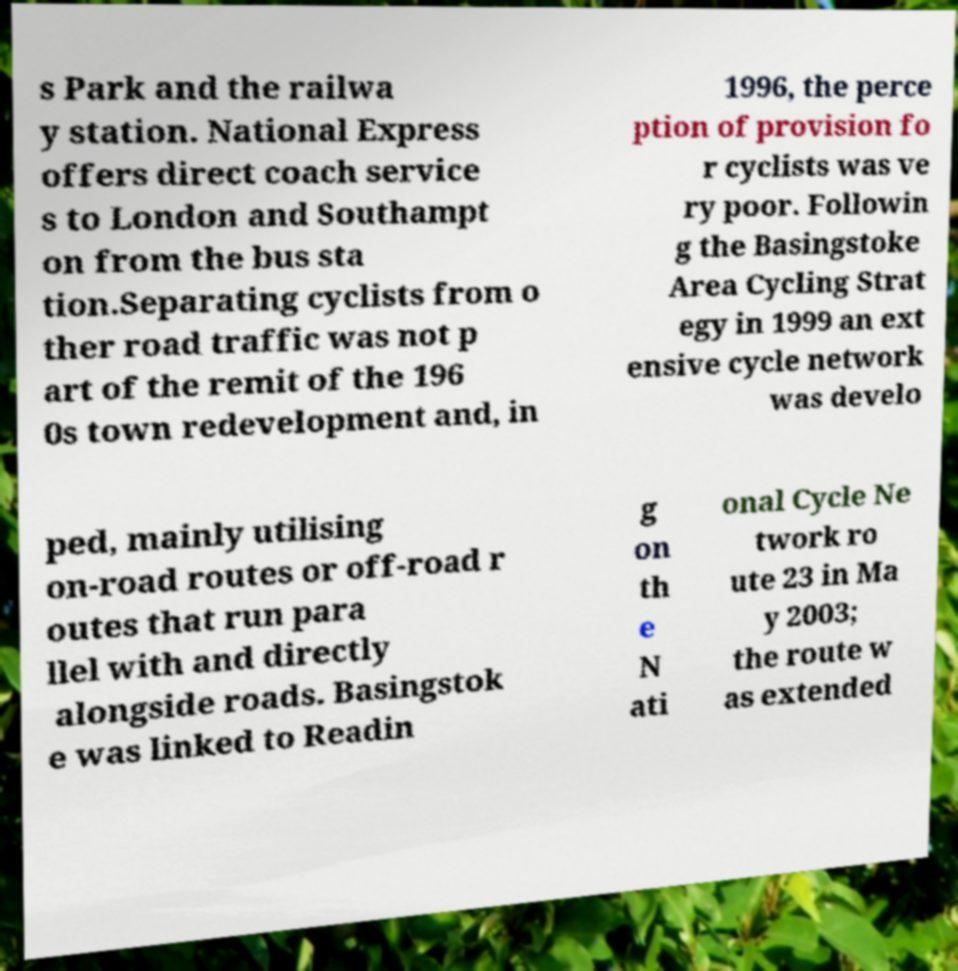What messages or text are displayed in this image? I need them in a readable, typed format. s Park and the railwa y station. National Express offers direct coach service s to London and Southampt on from the bus sta tion.Separating cyclists from o ther road traffic was not p art of the remit of the 196 0s town redevelopment and, in 1996, the perce ption of provision fo r cyclists was ve ry poor. Followin g the Basingstoke Area Cycling Strat egy in 1999 an ext ensive cycle network was develo ped, mainly utilising on-road routes or off-road r outes that run para llel with and directly alongside roads. Basingstok e was linked to Readin g on th e N ati onal Cycle Ne twork ro ute 23 in Ma y 2003; the route w as extended 